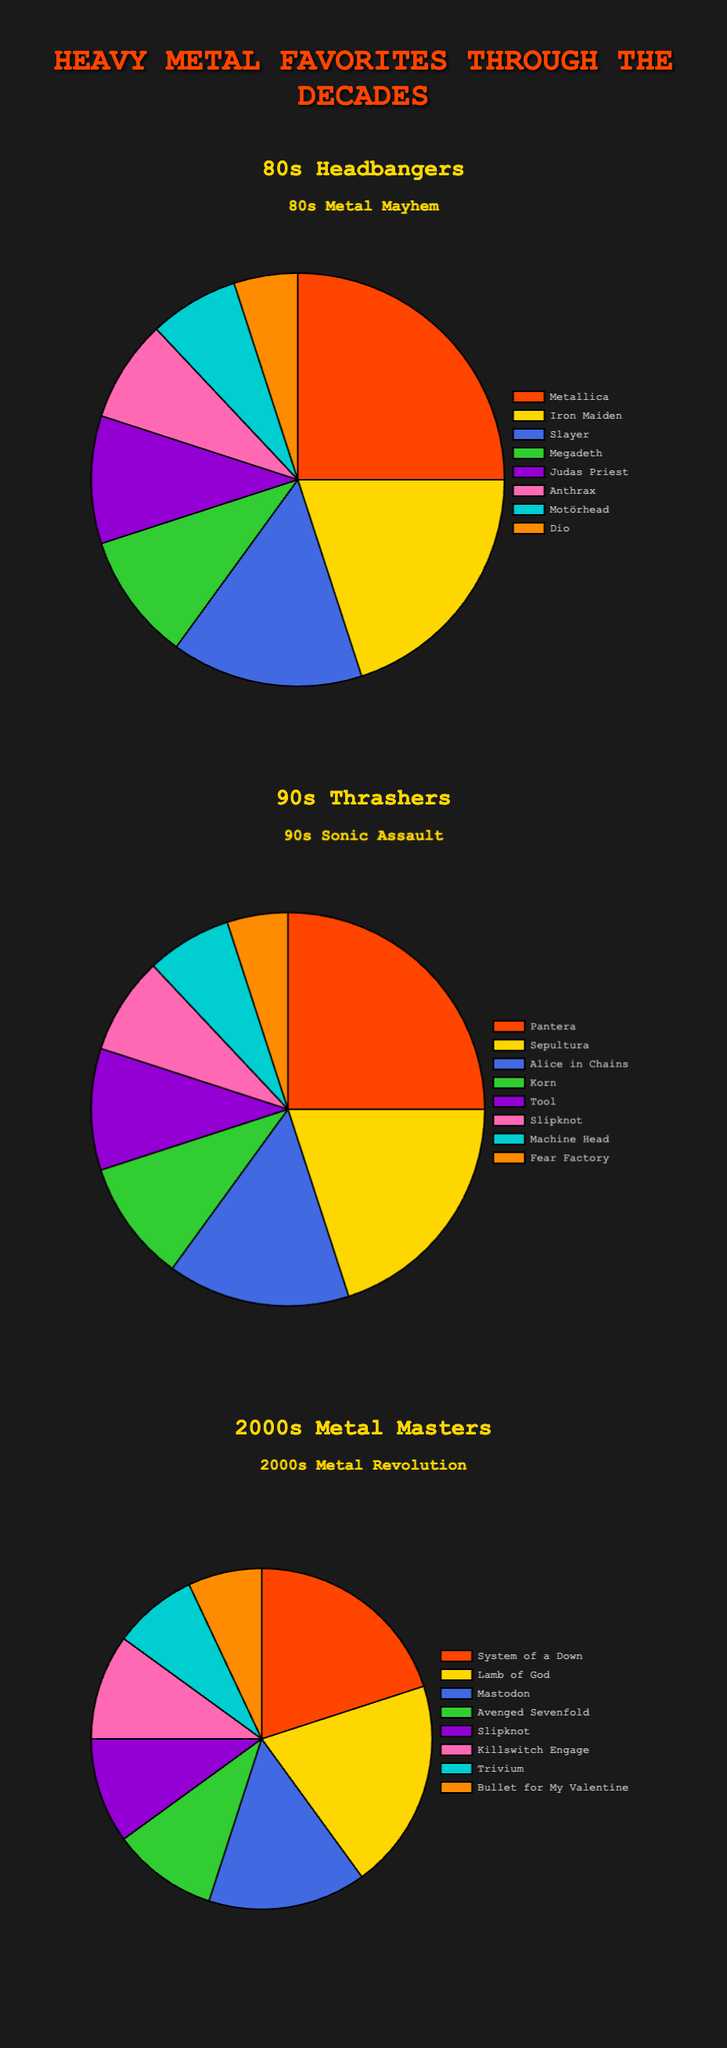Which band from the '80s has the largest fanbase? According to the '80s pie chart, Metallica has the largest portion of the pie at 25%, indicating it has the largest fanbase among the bands listed.
Answer: Metallica Which band has fans in both the '90s and the 2000s? Slipknot appears in both the '90s and 2000s data sets, with 8% and 10% respectively, showing that it maintained popularity across decades.
Answer: Slipknot How does Iron Maiden’s fanbase in the '80s compare to Pantera's in the '90s? Iron Maiden has 20% of the fanbase in the '80s, while Pantera has 25% in the '90s. Pantera's fanbase is larger.
Answer: Pantera's fanbase is larger Which band has the lowest percentage in its respective decade? In the '80s, Dio has the lowest at 5%. In the '90s, Fear Factory has the lowest at 5%. In the 2000s, Bullet for My Valentine has 7%, the lowest within that decade. Dio and Fear Factory are the lowest overall.
Answer: Dio (80s) and Fear Factory (90s) What is the combined fanbase percentage of Megadeth and Judas Priest in the '80s? Megadeth has 10% and Judas Priest has 10%, so their combined fanbase is 10% + 10% = 20%.
Answer: 20% Which band is tied with Tool in the '90s for their fanbase percentage? In the '90s section, both Tool and Korn have 10% each, making them tied.
Answer: Korn How much larger is Metallica’s '80s fanbase compared to Mastodon’s in the 2000s? Metallica's '80s fanbase is 25%, whereas Mastodon’s in the 2000s is 15%. The difference is 25% - 15% = 10%.
Answer: 10% Looking at the visual representation of colors, which band is represented by blue in the 2000s chart? The blue section in the 2000s chart represents System of a Down with 20%.
Answer: System of a Down Which decade has the most diversity in favorite bands' fanbases? The 2000s include more bands at percentages close to each other, indicating a more diverse distribution.
Answer: 2000s 